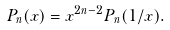<formula> <loc_0><loc_0><loc_500><loc_500>P _ { n } ( x ) = x ^ { 2 n - 2 } P _ { n } ( 1 / x ) .</formula> 